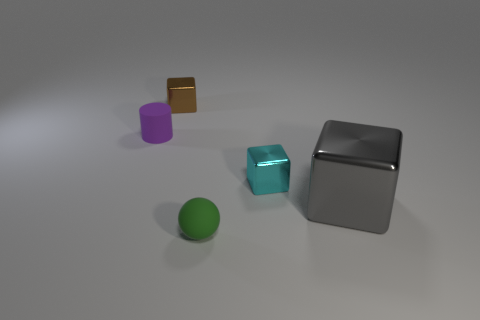Add 4 metallic cubes. How many objects exist? 9 Subtract all cylinders. How many objects are left? 4 Subtract 0 brown spheres. How many objects are left? 5 Subtract all tiny cubes. Subtract all purple rubber cylinders. How many objects are left? 2 Add 2 small brown metallic objects. How many small brown metallic objects are left? 3 Add 4 tiny things. How many tiny things exist? 8 